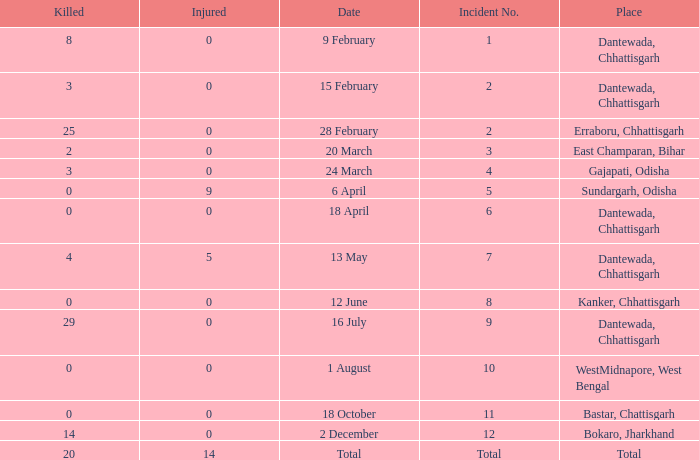What is the least amount of injuries in Dantewada, Chhattisgarh when 8 people were killed? 0.0. 